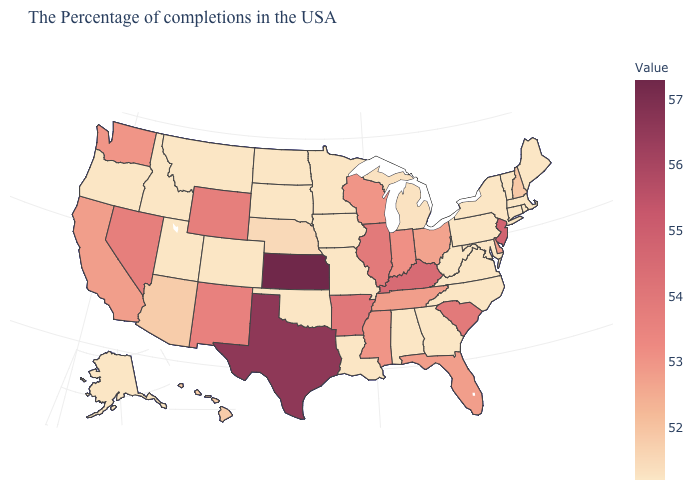Which states have the highest value in the USA?
Write a very short answer. Kansas. Among the states that border Connecticut , which have the lowest value?
Be succinct. Massachusetts, Rhode Island, New York. Is the legend a continuous bar?
Be succinct. Yes. Among the states that border Oregon , which have the highest value?
Write a very short answer. Nevada. Does the map have missing data?
Be succinct. No. Which states have the lowest value in the West?
Keep it brief. Colorado, Utah, Montana, Idaho, Oregon, Alaska. Among the states that border New Mexico , does Texas have the highest value?
Short answer required. Yes. 